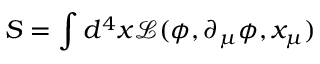Convert formula to latex. <formula><loc_0><loc_0><loc_500><loc_500>S = \int d ^ { 4 } x \mathcal { L } ( \phi , \partial _ { \mu } \phi , x _ { \mu } )</formula> 